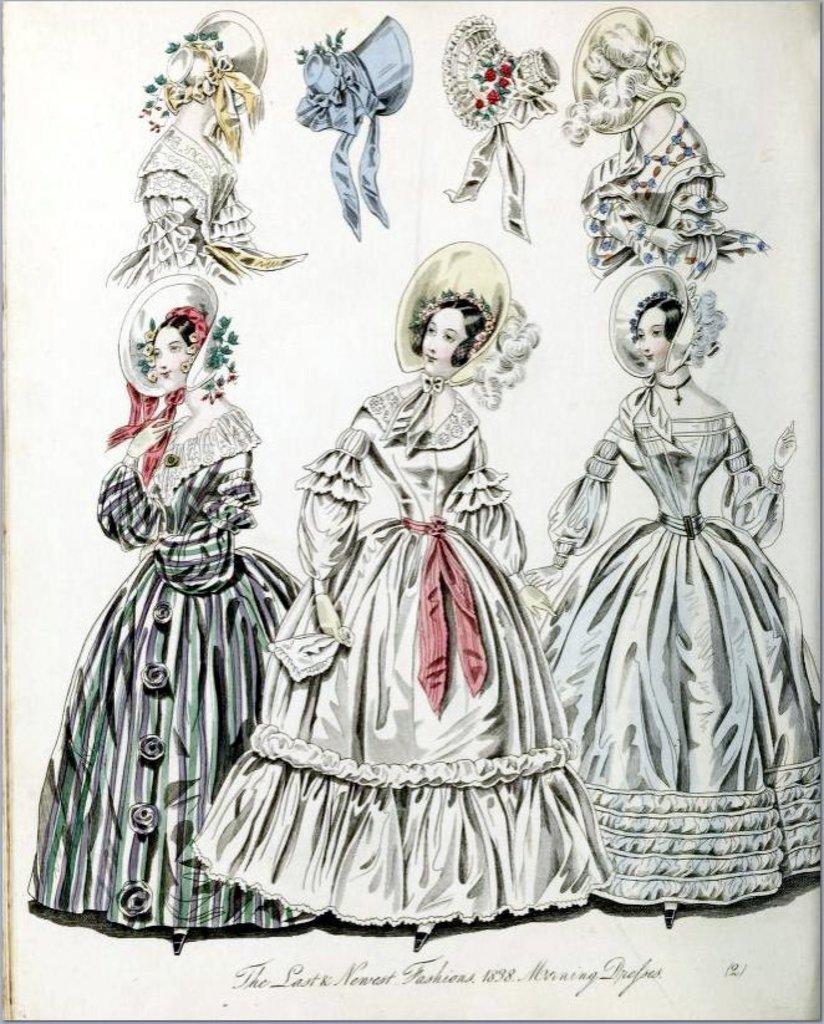What type of images can be seen in the picture? There are pictures of women and hats in the image. Where are these images located? These images are on a paper. What else is present on the paper besides the images? There is text at the bottom of the image. Can you tell me where the map is located in the image? There is no map present in the image; it features pictures of women and hats on a paper with text at the bottom. Is there a crown visible in the image? There is no crown present in the image. 